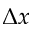<formula> <loc_0><loc_0><loc_500><loc_500>\Delta x</formula> 